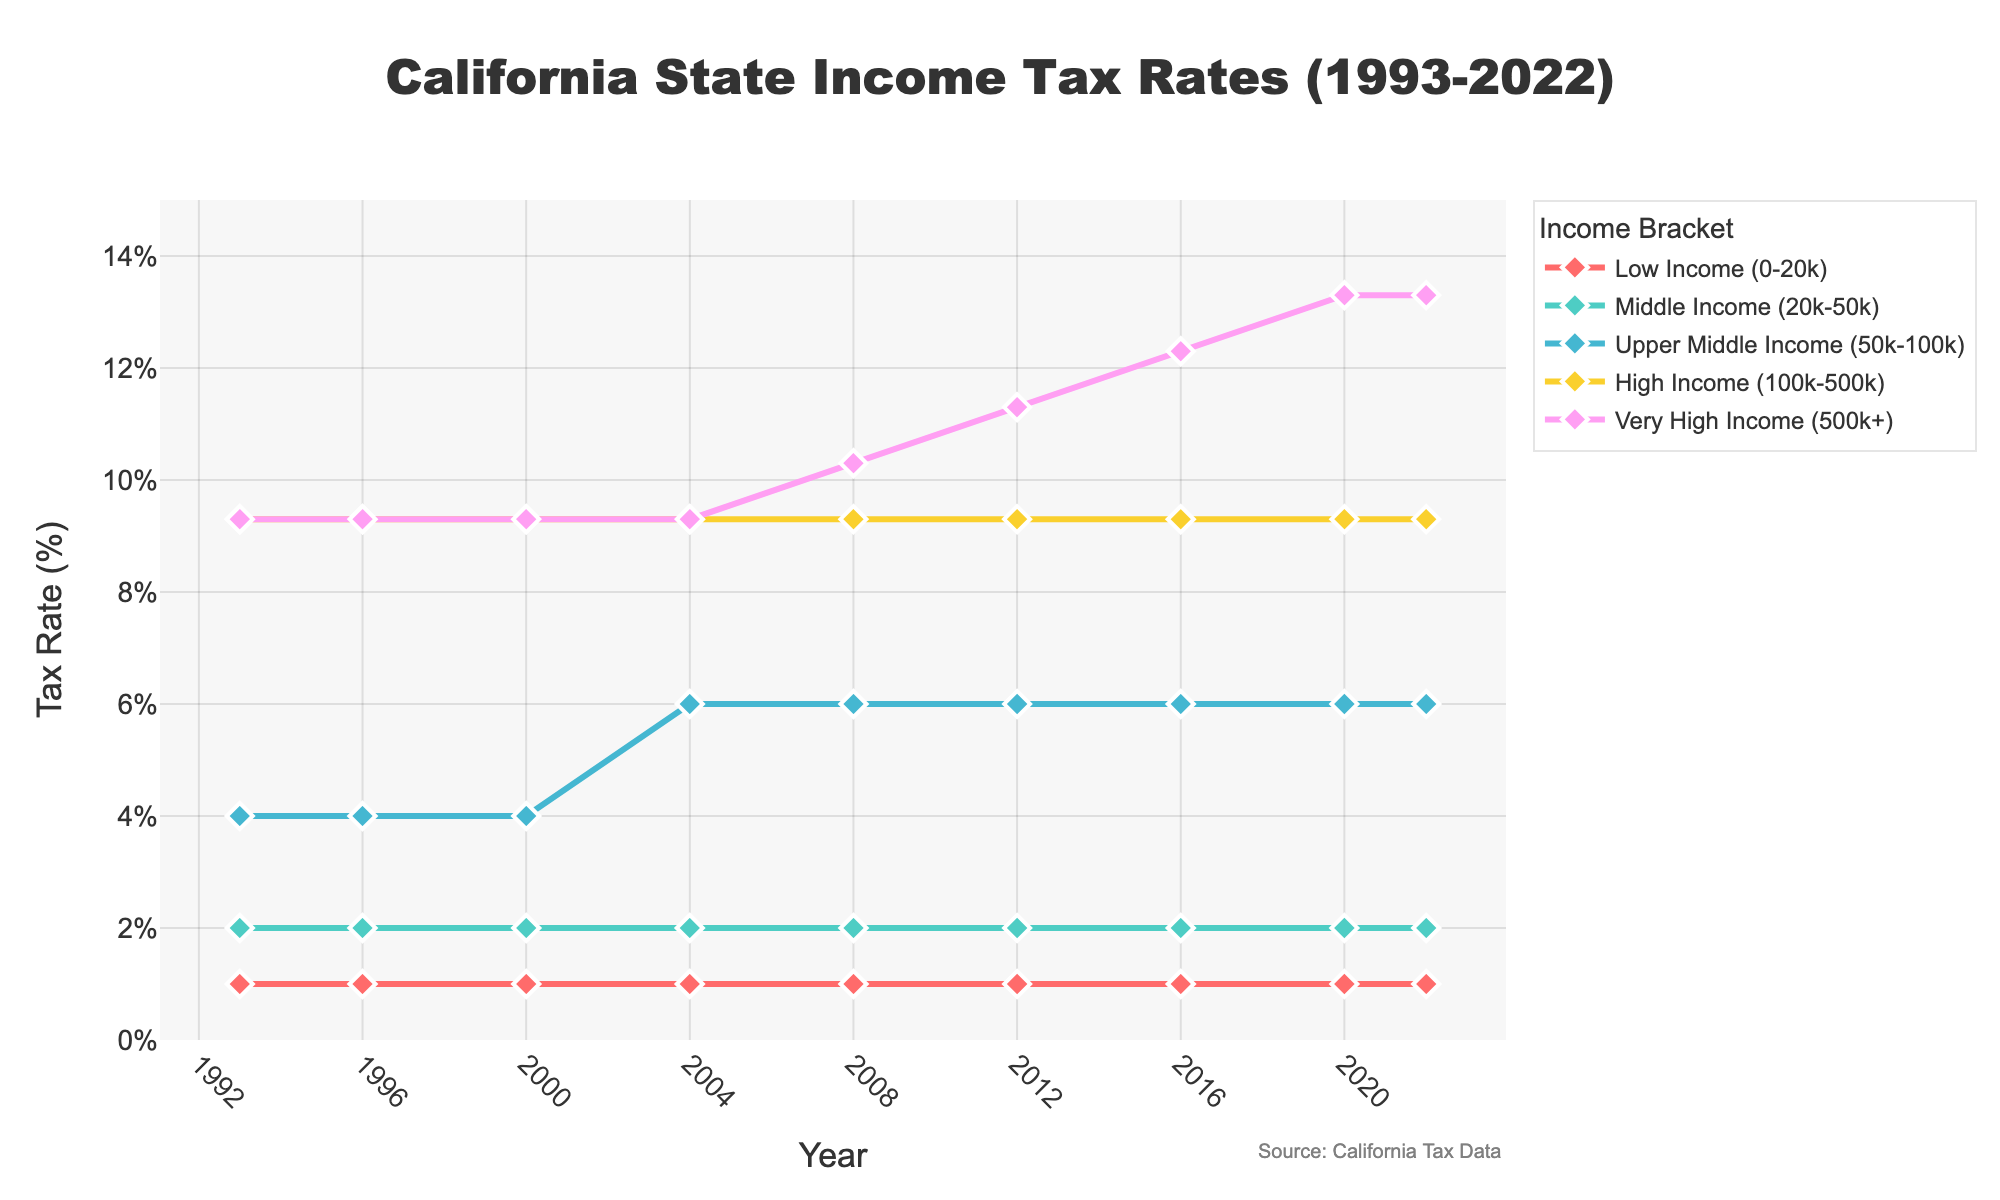What is the tax rate for the "High Income" bracket in 2008? The plot shows the tax rate for each year on the x-axis and the corresponding tax rates on the y-axis, with color-coded lines for each income bracket. In 2008, look at the position of the "High Income" bracket's line (yellow) to find the corresponding y-axis value.
Answer: 9.3% How did the tax rate for the "Very High Income" bracket change between 2008 and 2020? First, identify the tax rates for the "Very High Income" bracket (purple line) in 2008 and 2020 from the plot. Subtract the rate in 2008 from the rate in 2020. The change is obtained by (13.3 - 10.3).
Answer: 3% Which income bracket experienced the most significant tax rate increase from 1993 to 2022? Review the initial and final points of each income bracket's line on the plot to evaluate the changes. Compare the differences (2022 rate - 1993 rate) across all brackets. The "Very High Income" bracket shows the largest increase (13.3% - 9.3%).
Answer: Very High Income During which year did the "Upper Middle Income" tax rate increase, and by how much did it rise? Locate the years along the x-axis and track the "Upper Middle Income" line (blue) to spot any year where there is a noticeable increase. The tax rate increased to 6% in 2004. The rise from 4% to 6% (6 - 4) is 2%.
Answer: 2004, increased by 2% Compare the tax rates for "Middle Income" and "Upper Middle Income" brackets in 2016. Which one is higher and by how much? Identify the tax rates for both "Middle Income" (green) and "Upper Middle Income" (blue) brackets in 2016 from the plot. The "Middle Income" rate is 2% and the "Upper Middle Income" rate is 6%. Subtract the former from the latter (6 - 2).
Answer: Upper Middle Income is higher by 4% What was the average tax rate for the "Very High Income" bracket over the years shown? Add up the tax rates for the "Very High Income" bracket across all years displayed on the plot (9.3%, 9.3%, 9.3%, 9.3%, 10.3%, 11.3%, 12.3%, 13.3%, 13.3%). Then, divide the sum by the total number of years (9 years). The sum is 87.7, and the average is 87.7/9.
Answer: 9.74% Are there any years where all income brackets had the same tax rate? Observe the plot lines at each year to check if all lines converge at the same y-axis value. Specifically, confirm if at any year, "Low Income," "Middle Income," "Upper Middle Income," "High Income," and "Very High Income" levels coincide on the same tax rate. No such convergence is shown in the provided years.
Answer: No 